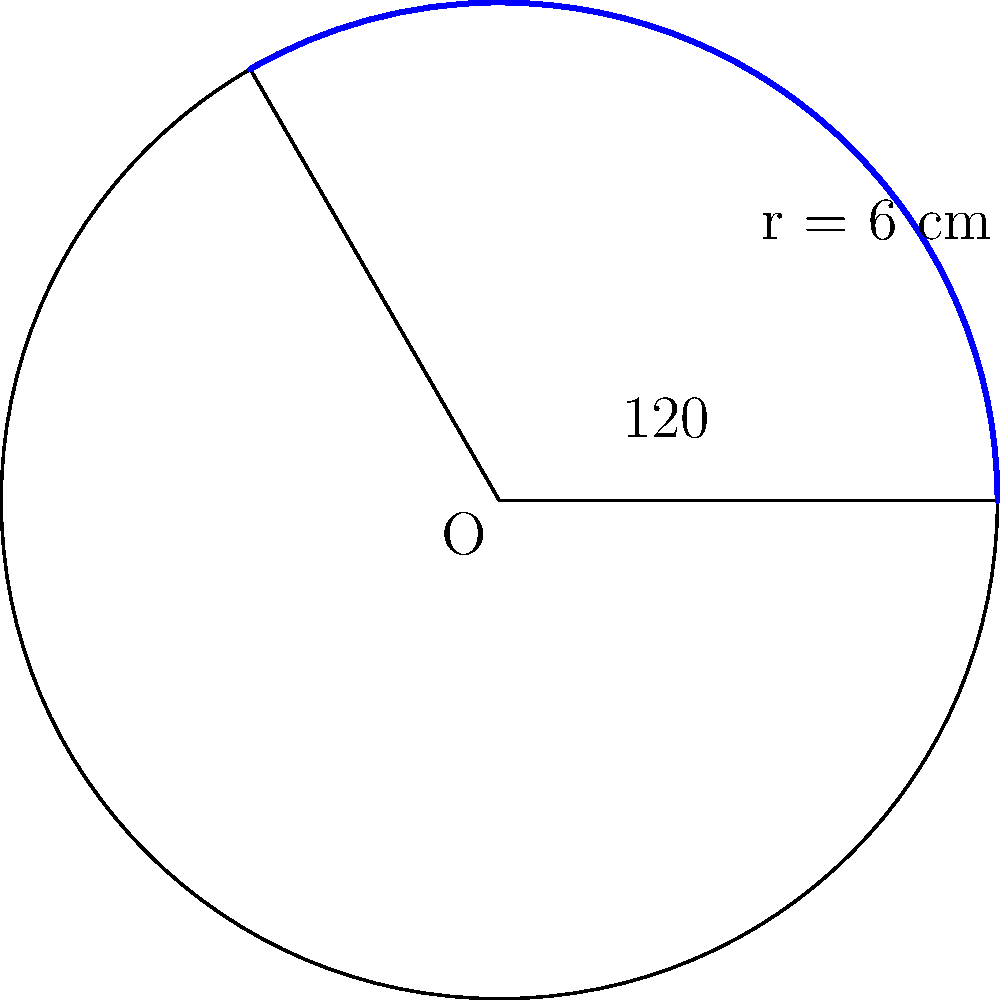A circular playground is designed for a special needs area in the school. The radius of the playground is 6 cm. If a sector of the playground needs to be covered with a soft material for safety reasons, and the central angle of this sector is 120°, what is the area of the sector that needs to be covered? Let's approach this step-by-step:

1) First, recall the formula for the area of a sector:
   Area of sector = $\frac{\theta}{360°} \times \pi r^2$
   where $\theta$ is the central angle in degrees and $r$ is the radius.

2) We're given:
   - Radius (r) = 6 cm
   - Central angle ($\theta$) = 120°

3) Let's substitute these values into our formula:
   Area = $\frac{120°}{360°} \times \pi (6 \text{ cm})^2$

4) Simplify the fraction:
   Area = $\frac{1}{3} \times \pi (6 \text{ cm})^2$

5) Calculate $6^2$:
   Area = $\frac{1}{3} \times \pi (36 \text{ cm}^2)$

6) Multiply:
   Area = $12\pi \text{ cm}^2$

7) If we need to give a decimal approximation:
   Area ≈ 37.7 cm² (rounded to one decimal place)

This result represents the area of the sector that needs to be covered with soft material for safety reasons.
Answer: $12\pi \text{ cm}^2$ or approximately 37.7 cm² 